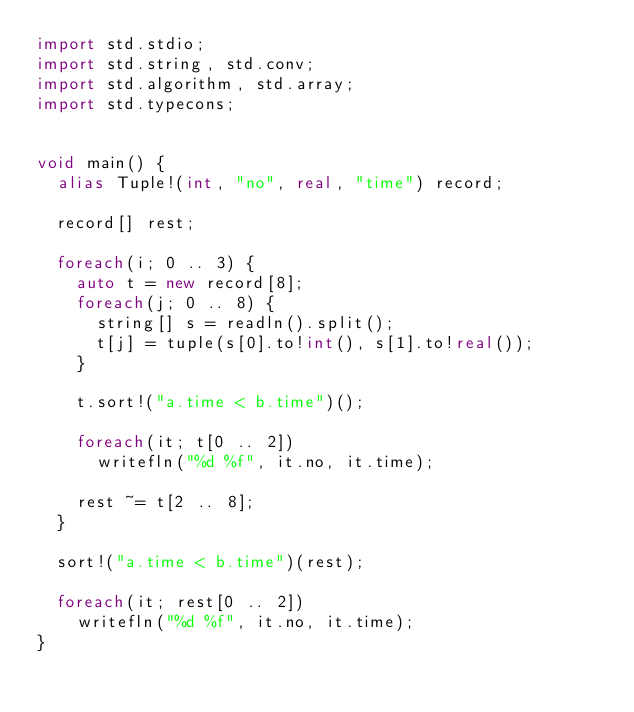Convert code to text. <code><loc_0><loc_0><loc_500><loc_500><_D_>import std.stdio;
import std.string, std.conv;
import std.algorithm, std.array;
import std.typecons;


void main() {
  alias Tuple!(int, "no", real, "time") record;

  record[] rest;

  foreach(i; 0 .. 3) {
    auto t = new record[8];
    foreach(j; 0 .. 8) {
      string[] s = readln().split();
      t[j] = tuple(s[0].to!int(), s[1].to!real());
    }

    t.sort!("a.time < b.time")();

    foreach(it; t[0 .. 2])
      writefln("%d %f", it.no, it.time);

    rest ~= t[2 .. 8];
  }

  sort!("a.time < b.time")(rest);

  foreach(it; rest[0 .. 2])
    writefln("%d %f", it.no, it.time);
}</code> 